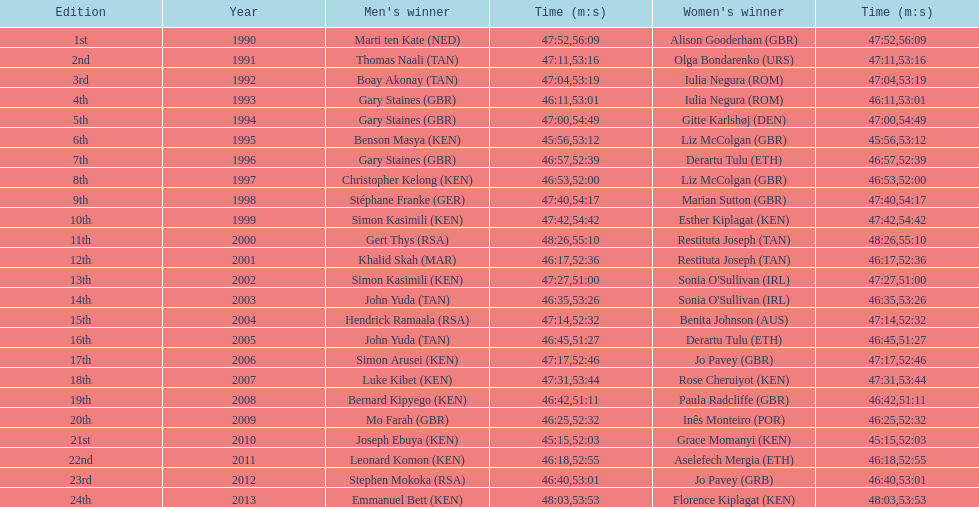What is the name of the first women's winner? Alison Gooderham. Could you parse the entire table as a dict? {'header': ['Edition', 'Year', "Men's winner", 'Time (m:s)', "Women's winner", 'Time (m:s)'], 'rows': [['1st', '1990', 'Marti ten Kate\xa0(NED)', '47:52', 'Alison Gooderham\xa0(GBR)', '56:09'], ['2nd', '1991', 'Thomas Naali\xa0(TAN)', '47:11', 'Olga Bondarenko\xa0(URS)', '53:16'], ['3rd', '1992', 'Boay Akonay\xa0(TAN)', '47:04', 'Iulia Negura\xa0(ROM)', '53:19'], ['4th', '1993', 'Gary Staines\xa0(GBR)', '46:11', 'Iulia Negura\xa0(ROM)', '53:01'], ['5th', '1994', 'Gary Staines\xa0(GBR)', '47:00', 'Gitte Karlshøj\xa0(DEN)', '54:49'], ['6th', '1995', 'Benson Masya\xa0(KEN)', '45:56', 'Liz McColgan\xa0(GBR)', '53:12'], ['7th', '1996', 'Gary Staines\xa0(GBR)', '46:57', 'Derartu Tulu\xa0(ETH)', '52:39'], ['8th', '1997', 'Christopher Kelong\xa0(KEN)', '46:53', 'Liz McColgan\xa0(GBR)', '52:00'], ['9th', '1998', 'Stéphane Franke\xa0(GER)', '47:40', 'Marian Sutton\xa0(GBR)', '54:17'], ['10th', '1999', 'Simon Kasimili\xa0(KEN)', '47:42', 'Esther Kiplagat\xa0(KEN)', '54:42'], ['11th', '2000', 'Gert Thys\xa0(RSA)', '48:26', 'Restituta Joseph\xa0(TAN)', '55:10'], ['12th', '2001', 'Khalid Skah\xa0(MAR)', '46:17', 'Restituta Joseph\xa0(TAN)', '52:36'], ['13th', '2002', 'Simon Kasimili\xa0(KEN)', '47:27', "Sonia O'Sullivan\xa0(IRL)", '51:00'], ['14th', '2003', 'John Yuda\xa0(TAN)', '46:35', "Sonia O'Sullivan\xa0(IRL)", '53:26'], ['15th', '2004', 'Hendrick Ramaala\xa0(RSA)', '47:14', 'Benita Johnson\xa0(AUS)', '52:32'], ['16th', '2005', 'John Yuda\xa0(TAN)', '46:45', 'Derartu Tulu\xa0(ETH)', '51:27'], ['17th', '2006', 'Simon Arusei\xa0(KEN)', '47:17', 'Jo Pavey\xa0(GBR)', '52:46'], ['18th', '2007', 'Luke Kibet\xa0(KEN)', '47:31', 'Rose Cheruiyot\xa0(KEN)', '53:44'], ['19th', '2008', 'Bernard Kipyego\xa0(KEN)', '46:42', 'Paula Radcliffe\xa0(GBR)', '51:11'], ['20th', '2009', 'Mo Farah\xa0(GBR)', '46:25', 'Inês Monteiro\xa0(POR)', '52:32'], ['21st', '2010', 'Joseph Ebuya\xa0(KEN)', '45:15', 'Grace Momanyi\xa0(KEN)', '52:03'], ['22nd', '2011', 'Leonard Komon\xa0(KEN)', '46:18', 'Aselefech Mergia\xa0(ETH)', '52:55'], ['23rd', '2012', 'Stephen Mokoka\xa0(RSA)', '46:40', 'Jo Pavey\xa0(GRB)', '53:01'], ['24th', '2013', 'Emmanuel Bett\xa0(KEN)', '48:03', 'Florence Kiplagat\xa0(KEN)', '53:53']]} 